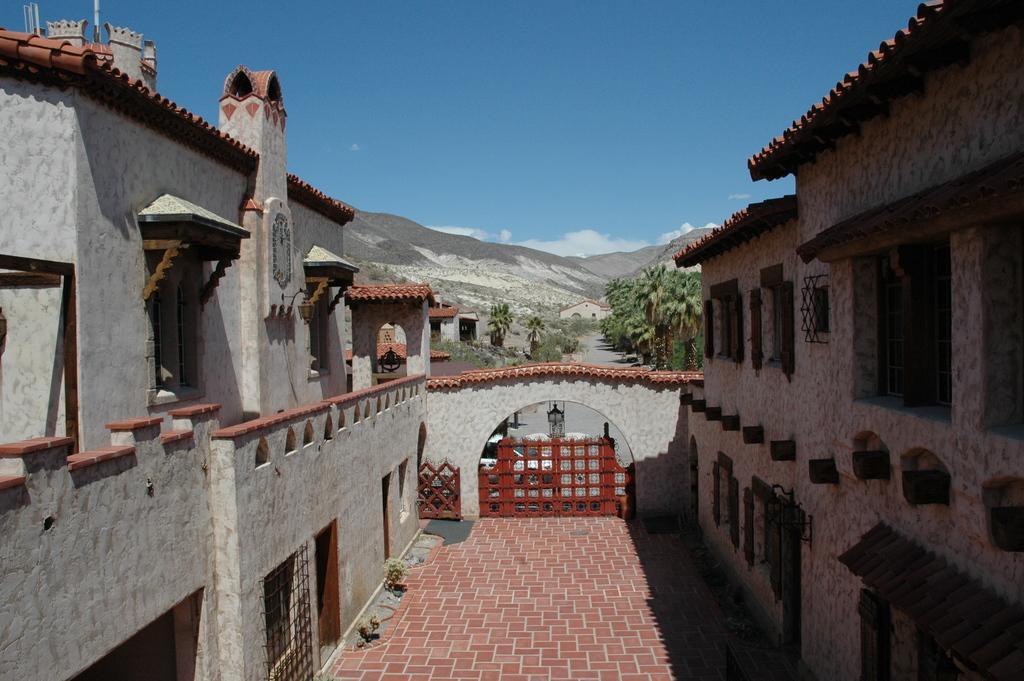In one or two sentences, can you explain what this image depicts? In this image I can see few buildings, windows, trees, mountains and the sky is in blue and white color. 